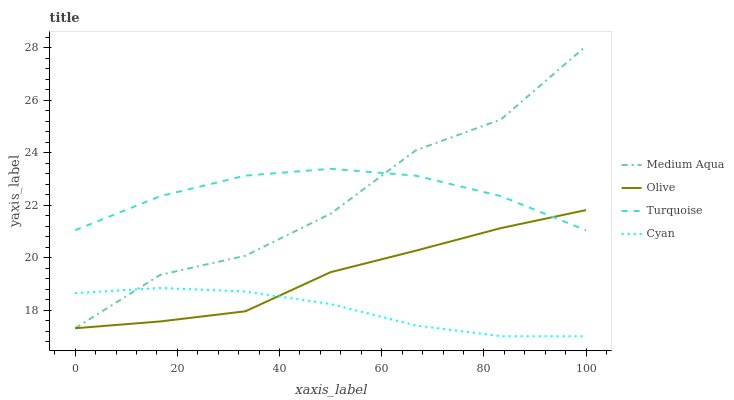Does Cyan have the minimum area under the curve?
Answer yes or no. Yes. Does Turquoise have the maximum area under the curve?
Answer yes or no. Yes. Does Turquoise have the minimum area under the curve?
Answer yes or no. No. Does Cyan have the maximum area under the curve?
Answer yes or no. No. Is Cyan the smoothest?
Answer yes or no. Yes. Is Medium Aqua the roughest?
Answer yes or no. Yes. Is Turquoise the smoothest?
Answer yes or no. No. Is Turquoise the roughest?
Answer yes or no. No. Does Cyan have the lowest value?
Answer yes or no. Yes. Does Turquoise have the lowest value?
Answer yes or no. No. Does Medium Aqua have the highest value?
Answer yes or no. Yes. Does Turquoise have the highest value?
Answer yes or no. No. Is Cyan less than Turquoise?
Answer yes or no. Yes. Is Turquoise greater than Cyan?
Answer yes or no. Yes. Does Olive intersect Turquoise?
Answer yes or no. Yes. Is Olive less than Turquoise?
Answer yes or no. No. Is Olive greater than Turquoise?
Answer yes or no. No. Does Cyan intersect Turquoise?
Answer yes or no. No. 